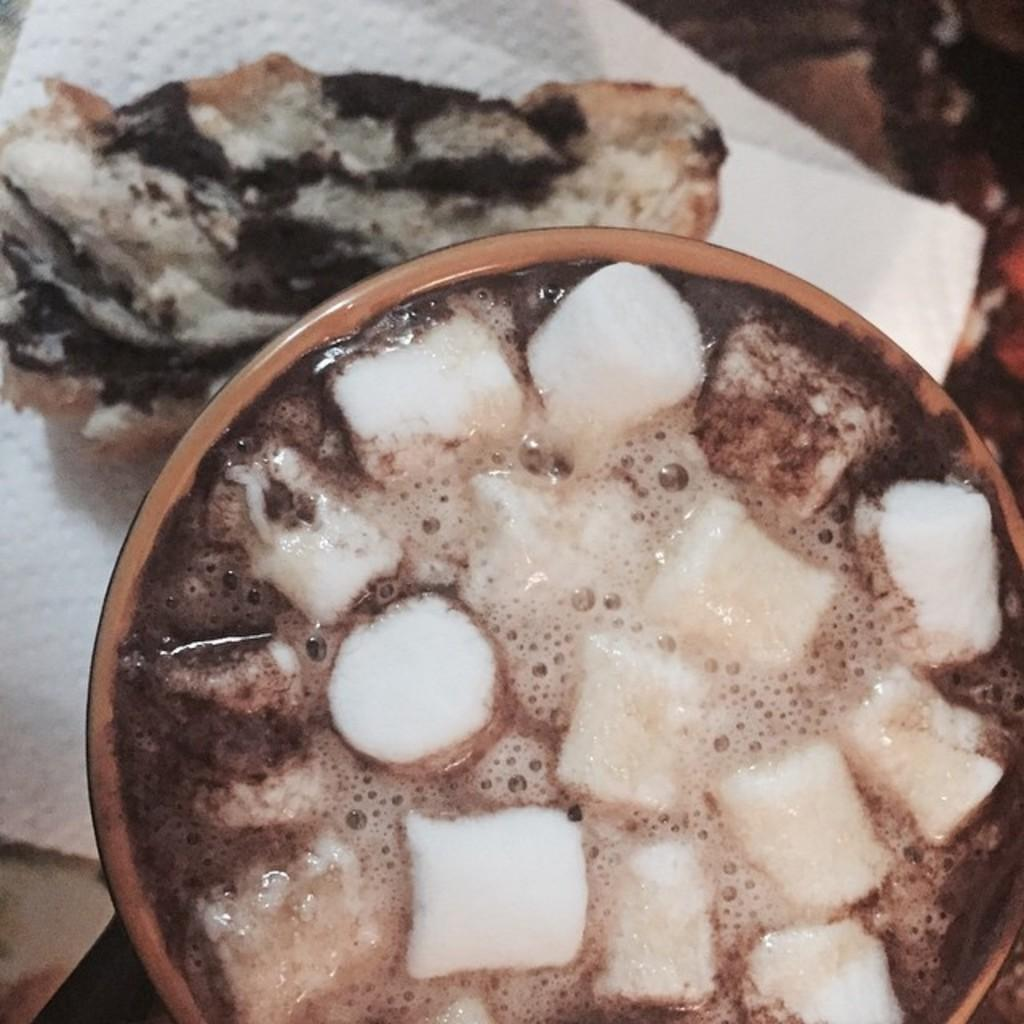What is present in the image that can hold items? There is a bowl in the image. What is inside the bowl? There is a food item in the bowl. What type of material is inside the bowl with the food item? There is tissue paper inside the bowl. What type of sweater is being worn by the food item in the image? There is no sweater present in the image, as the food item is not a person or an animal that would wear clothing. 